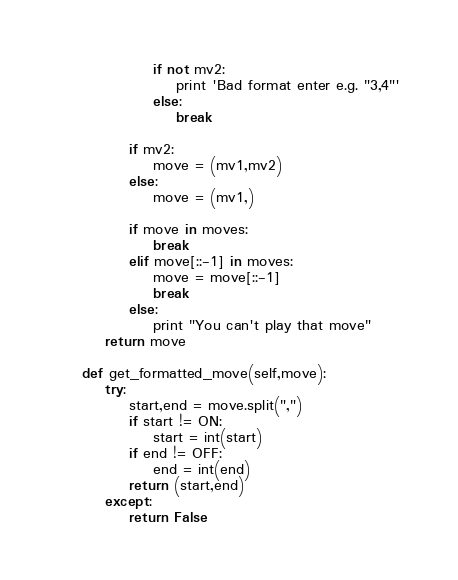<code> <loc_0><loc_0><loc_500><loc_500><_Python_>                if not mv2:
                    print 'Bad format enter e.g. "3,4"'
                else:
                    break

            if mv2:
                move = (mv1,mv2)
            else:
                move = (mv1,)

            if move in moves:
                break
            elif move[::-1] in moves:
                move = move[::-1]
                break
            else:
                print "You can't play that move"
        return move

    def get_formatted_move(self,move):
        try:
            start,end = move.split(",")
            if start != ON:
                start = int(start)
            if end != OFF:
                end = int(end)
            return (start,end)
        except:
            return False
</code> 